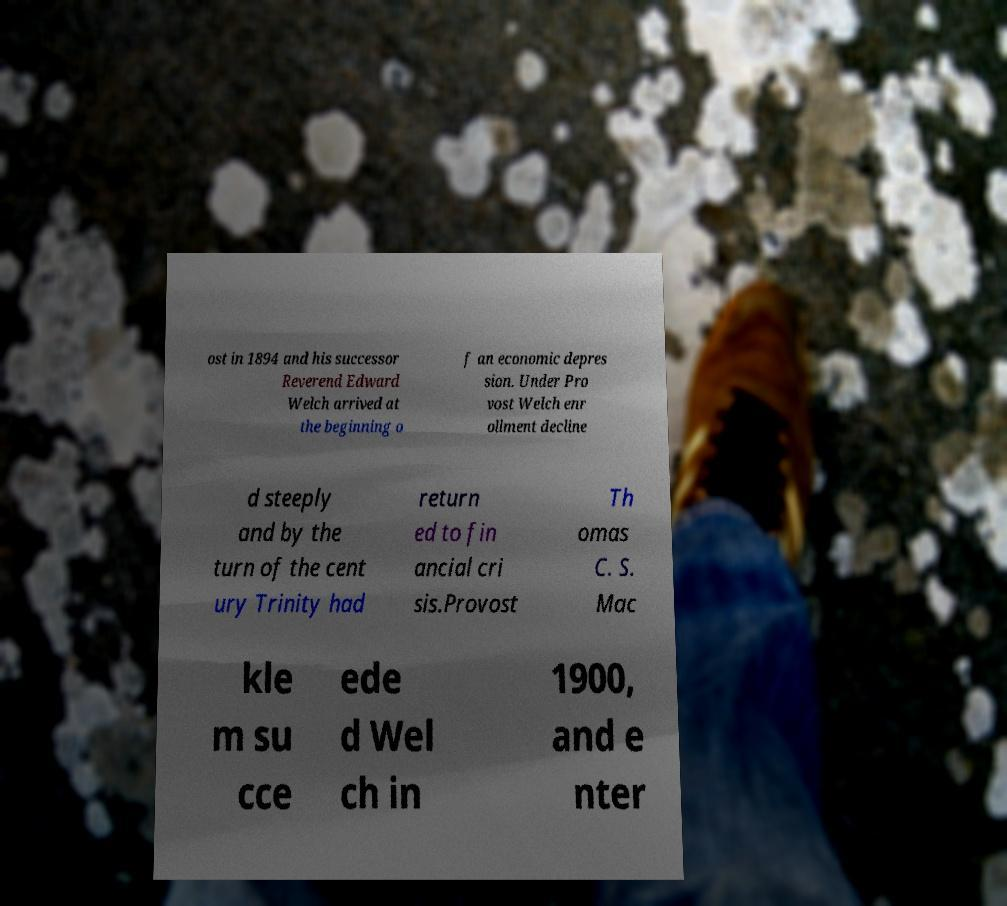Please read and relay the text visible in this image. What does it say? ost in 1894 and his successor Reverend Edward Welch arrived at the beginning o f an economic depres sion. Under Pro vost Welch enr ollment decline d steeply and by the turn of the cent ury Trinity had return ed to fin ancial cri sis.Provost Th omas C. S. Mac kle m su cce ede d Wel ch in 1900, and e nter 